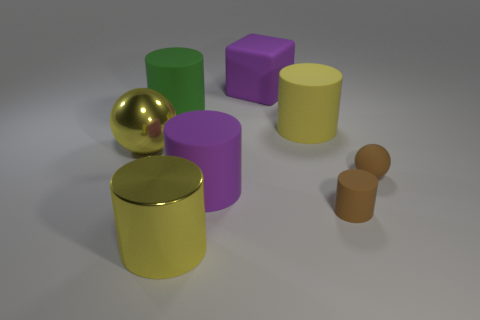Is the color of the metallic sphere the same as the large shiny cylinder?
Ensure brevity in your answer.  Yes. The object that is the same color as the small matte cylinder is what size?
Make the answer very short. Small. What is the color of the matte cube that is the same size as the green cylinder?
Your answer should be very brief. Purple. There is a large metallic cylinder; is its color the same as the sphere left of the big purple cube?
Your answer should be compact. Yes. What is the material of the large purple object behind the yellow object that is left of the green matte thing?
Ensure brevity in your answer.  Rubber. How many large things are to the right of the yellow metal ball and in front of the purple block?
Your answer should be very brief. 4. What number of other things are there of the same size as the purple matte cylinder?
Your answer should be compact. 5. There is a purple object that is in front of the green cylinder; is it the same shape as the small brown rubber object to the left of the brown rubber ball?
Make the answer very short. Yes. Are there any objects in front of the large yellow rubber cylinder?
Ensure brevity in your answer.  Yes. There is a big metal thing that is the same shape as the large green matte thing; what color is it?
Offer a terse response. Yellow. 